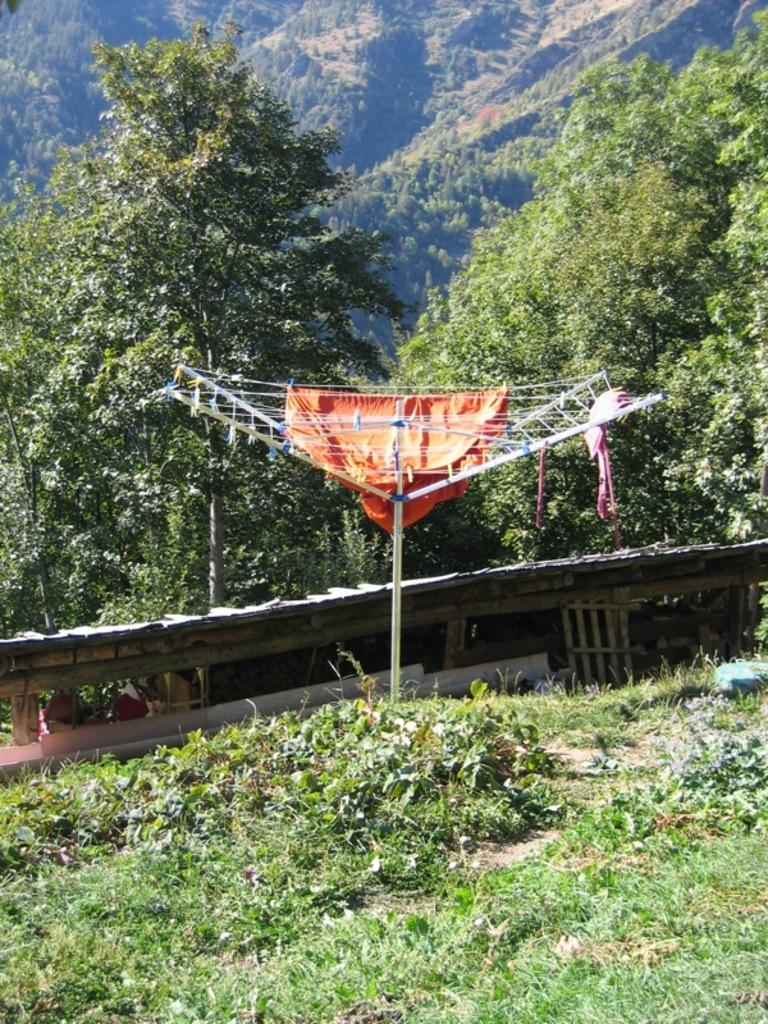What is hanging on the cloth dryer stand in the image? There are clothes on a cloth dryer stand in the image. What type of natural environment is visible in the image? There is grass visible in the image. What type of material is used for the objects in the image? There are wooden objects in the image. What is on the ground in the image? There are objects on the ground in the image. What can be seen in the distance in the image? There are trees in the background of the image. What season is depicted in the image? The image does not depict a specific season, as there are no seasonal indicators present. 